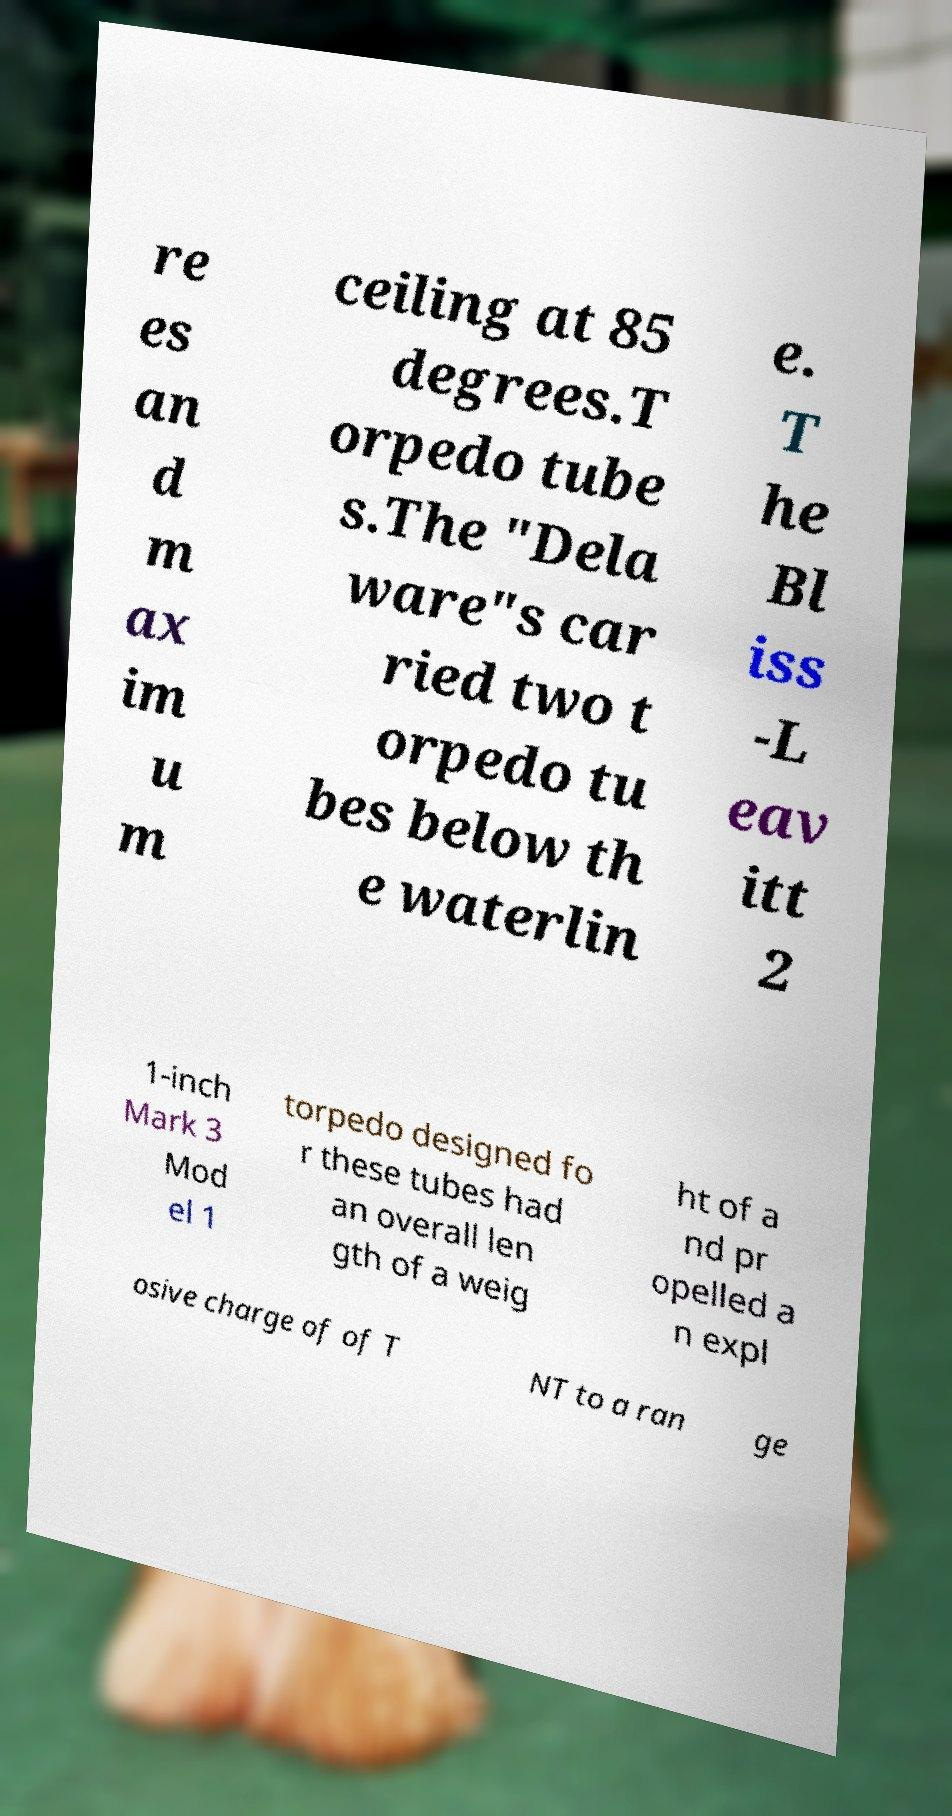Please read and relay the text visible in this image. What does it say? re es an d m ax im u m ceiling at 85 degrees.T orpedo tube s.The "Dela ware"s car ried two t orpedo tu bes below th e waterlin e. T he Bl iss -L eav itt 2 1-inch Mark 3 Mod el 1 torpedo designed fo r these tubes had an overall len gth of a weig ht of a nd pr opelled a n expl osive charge of of T NT to a ran ge 